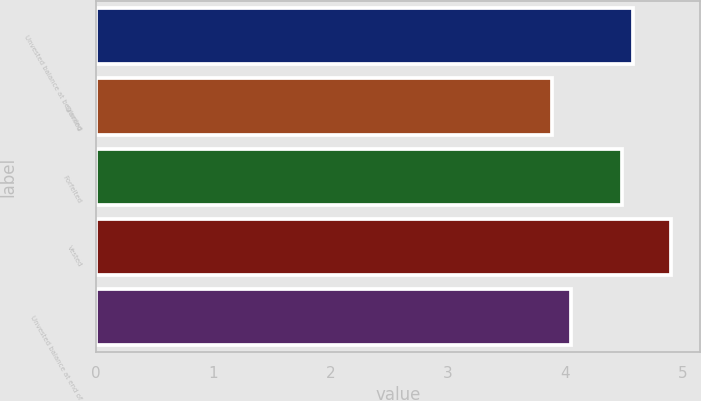Convert chart to OTSL. <chart><loc_0><loc_0><loc_500><loc_500><bar_chart><fcel>Unvested balance at beginning<fcel>Granted<fcel>Forfeited<fcel>Vested<fcel>Unvested balance at end of<nl><fcel>4.58<fcel>3.89<fcel>4.48<fcel>4.9<fcel>4.05<nl></chart> 